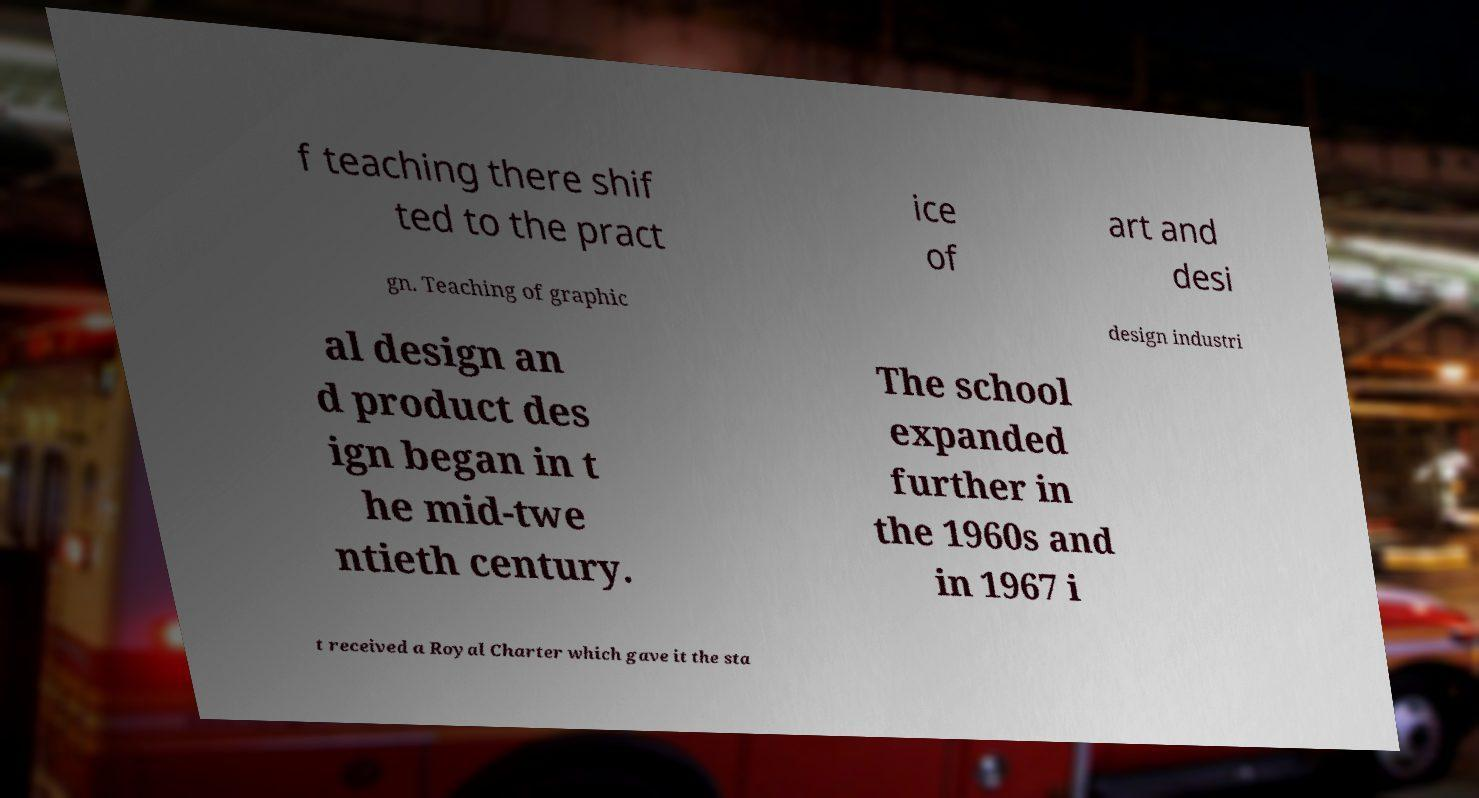Could you assist in decoding the text presented in this image and type it out clearly? f teaching there shif ted to the pract ice of art and desi gn. Teaching of graphic design industri al design an d product des ign began in t he mid-twe ntieth century. The school expanded further in the 1960s and in 1967 i t received a Royal Charter which gave it the sta 